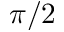Convert formula to latex. <formula><loc_0><loc_0><loc_500><loc_500>\pi / 2</formula> 